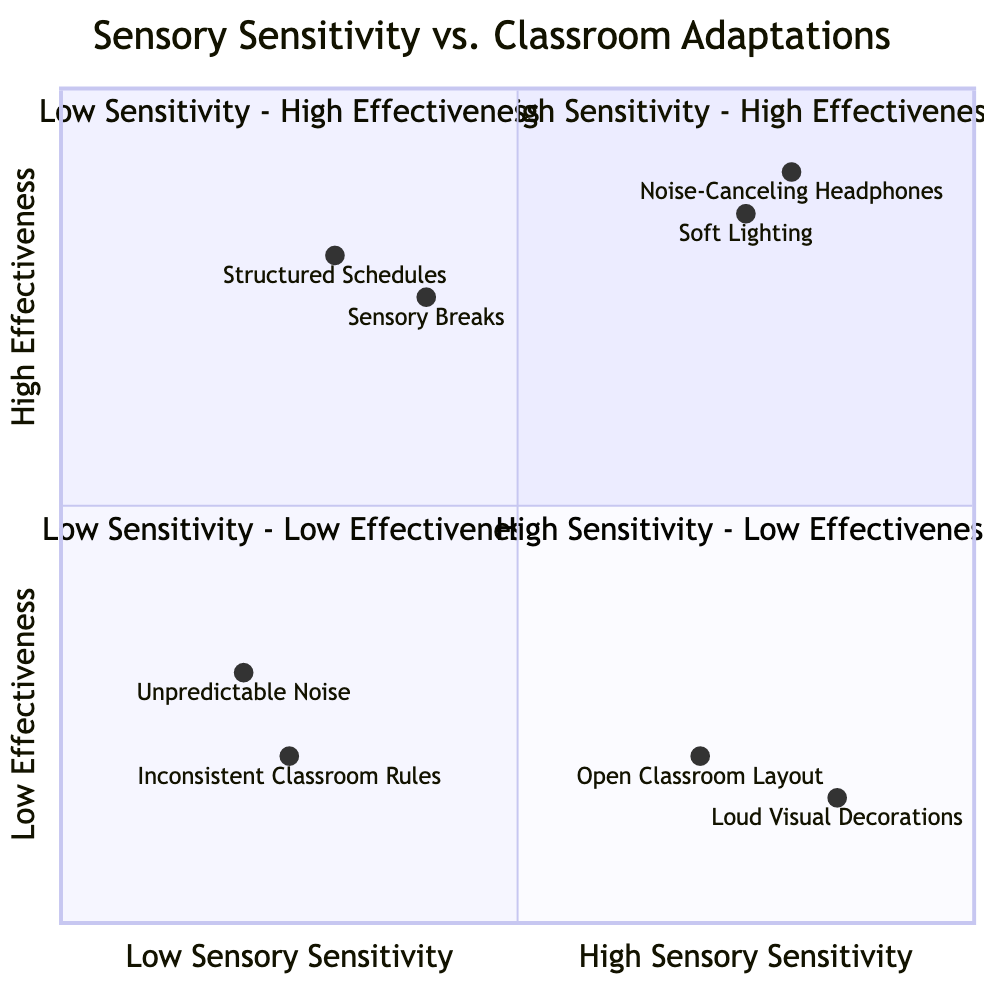What are the elements in the "High Sensory Sensitivity - High Effectiveness" quadrant? The elements listed in this quadrant are "Noise-Canceling Headphones" and "Soft Lighting". These are specifically designed strategies that effectively aid children with high sensory sensitivity.
Answer: Noise-Canceling Headphones, Soft Lighting How many elements are there in the "Low Sensory Sensitivity - Low Effectiveness" quadrant? There are two elements present in the "Low Sensory Sensitivity - Low Effectiveness" quadrant: "Unpredictable Noise" and "Inconsistent Classroom Rules".
Answer: 2 What is the effectiveness rating of "Noise-Canceling Headphones"? The effectiveness rating for "Noise-Canceling Headphones" is 0.9, indicating it is very effective for children with high sensory sensitivity.
Answer: 0.9 Which adaptation has the lowest effectiveness in "High Sensory Sensitivity - Low Effectiveness"? The adaptation with the lowest effectiveness in this quadrant is "Loud Visual Decorations", which has an effectiveness rating of 0.15.
Answer: Loud Visual Decorations What do the adjectives "High" and "Low" signify on both axes? "High" on the x-axis refers to increased sensory sensitivity levels, while "Low" indicates decreased sensory sensitivity levels. Similarly, "High" on the y-axis signifies greater effectiveness of classroom adaptations, and "Low" indicates lesser effectiveness.
Answer: High refers to increased levels; Low refers to decreased levels Which strategy appears in both "High Sensory Sensitivity - High Effectiveness" and "Low Sensory Sensitivity - High Effectiveness" quadrants? There are no strategies that appear in both quadrants. Each quadrant contains unique adaptations tailored to specific sensitivity levels and effectiveness ratings.
Answer: None In which quadrant does "Structured Schedules" appear? "Structured Schedules" is located in the "Low Sensory Sensitivity - High Effectiveness" quadrant, where structured routines are deemed effective for children with low sensory sensitivity.
Answer: Low Sensory Sensitivity - High Effectiveness If a child has high sensory sensitivity, which two elements are most effective? For a child with high sensory sensitivity, the most effective elements are "Noise-Canceling Headphones" and "Soft Lighting", both positioned in the first quadrant.
Answer: Noise-Canceling Headphones, Soft Lighting What is the effectiveness rating of "Inconsistent Classroom Rules"? The effectiveness rating for "Inconsistent Classroom Rules" is 0.2, indicating it has low effectiveness in managing classroom behavior.
Answer: 0.2 